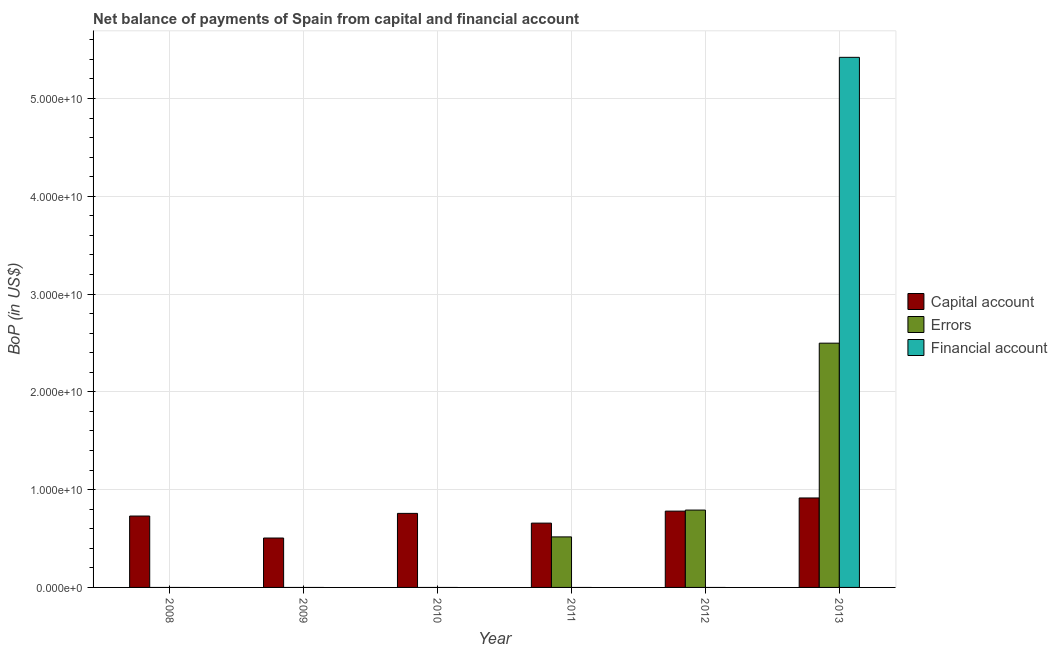Are the number of bars on each tick of the X-axis equal?
Your answer should be compact. No. How many bars are there on the 3rd tick from the right?
Your answer should be very brief. 2. What is the label of the 5th group of bars from the left?
Provide a succinct answer. 2012. What is the amount of net capital account in 2010?
Keep it short and to the point. 7.57e+09. Across all years, what is the maximum amount of net capital account?
Give a very brief answer. 9.15e+09. What is the total amount of financial account in the graph?
Keep it short and to the point. 5.42e+1. What is the difference between the amount of errors in 2011 and that in 2012?
Your answer should be very brief. -2.74e+09. What is the average amount of errors per year?
Your response must be concise. 6.34e+09. In how many years, is the amount of errors greater than 40000000000 US$?
Your answer should be compact. 0. What is the ratio of the amount of net capital account in 2009 to that in 2013?
Provide a succinct answer. 0.55. Is the amount of errors in 2011 less than that in 2012?
Your answer should be very brief. Yes. What is the difference between the highest and the second highest amount of net capital account?
Offer a very short reply. 1.35e+09. What is the difference between the highest and the lowest amount of financial account?
Provide a short and direct response. 5.42e+1. Are the values on the major ticks of Y-axis written in scientific E-notation?
Keep it short and to the point. Yes. Does the graph contain any zero values?
Provide a succinct answer. Yes. Does the graph contain grids?
Offer a terse response. Yes. Where does the legend appear in the graph?
Your response must be concise. Center right. How many legend labels are there?
Your response must be concise. 3. What is the title of the graph?
Your answer should be compact. Net balance of payments of Spain from capital and financial account. Does "Taxes" appear as one of the legend labels in the graph?
Ensure brevity in your answer.  No. What is the label or title of the X-axis?
Offer a terse response. Year. What is the label or title of the Y-axis?
Keep it short and to the point. BoP (in US$). What is the BoP (in US$) of Capital account in 2008?
Ensure brevity in your answer.  7.30e+09. What is the BoP (in US$) in Capital account in 2009?
Your response must be concise. 5.05e+09. What is the BoP (in US$) of Errors in 2009?
Provide a succinct answer. 0. What is the BoP (in US$) in Capital account in 2010?
Your answer should be very brief. 7.57e+09. What is the BoP (in US$) of Financial account in 2010?
Your answer should be compact. 0. What is the BoP (in US$) in Capital account in 2011?
Provide a succinct answer. 6.58e+09. What is the BoP (in US$) of Errors in 2011?
Give a very brief answer. 5.17e+09. What is the BoP (in US$) of Capital account in 2012?
Your response must be concise. 7.81e+09. What is the BoP (in US$) in Errors in 2012?
Your response must be concise. 7.91e+09. What is the BoP (in US$) in Capital account in 2013?
Keep it short and to the point. 9.15e+09. What is the BoP (in US$) of Errors in 2013?
Your answer should be compact. 2.50e+1. What is the BoP (in US$) of Financial account in 2013?
Ensure brevity in your answer.  5.42e+1. Across all years, what is the maximum BoP (in US$) of Capital account?
Make the answer very short. 9.15e+09. Across all years, what is the maximum BoP (in US$) of Errors?
Keep it short and to the point. 2.50e+1. Across all years, what is the maximum BoP (in US$) in Financial account?
Ensure brevity in your answer.  5.42e+1. Across all years, what is the minimum BoP (in US$) of Capital account?
Offer a very short reply. 5.05e+09. Across all years, what is the minimum BoP (in US$) in Financial account?
Keep it short and to the point. 0. What is the total BoP (in US$) in Capital account in the graph?
Make the answer very short. 4.35e+1. What is the total BoP (in US$) in Errors in the graph?
Provide a succinct answer. 3.81e+1. What is the total BoP (in US$) of Financial account in the graph?
Keep it short and to the point. 5.42e+1. What is the difference between the BoP (in US$) of Capital account in 2008 and that in 2009?
Provide a short and direct response. 2.25e+09. What is the difference between the BoP (in US$) in Capital account in 2008 and that in 2010?
Offer a very short reply. -2.73e+08. What is the difference between the BoP (in US$) of Capital account in 2008 and that in 2011?
Make the answer very short. 7.24e+08. What is the difference between the BoP (in US$) of Capital account in 2008 and that in 2012?
Your response must be concise. -5.05e+08. What is the difference between the BoP (in US$) in Capital account in 2008 and that in 2013?
Offer a terse response. -1.85e+09. What is the difference between the BoP (in US$) of Capital account in 2009 and that in 2010?
Your response must be concise. -2.52e+09. What is the difference between the BoP (in US$) in Capital account in 2009 and that in 2011?
Ensure brevity in your answer.  -1.52e+09. What is the difference between the BoP (in US$) in Capital account in 2009 and that in 2012?
Your answer should be very brief. -2.75e+09. What is the difference between the BoP (in US$) in Capital account in 2009 and that in 2013?
Provide a short and direct response. -4.10e+09. What is the difference between the BoP (in US$) in Capital account in 2010 and that in 2011?
Your answer should be compact. 9.97e+08. What is the difference between the BoP (in US$) in Capital account in 2010 and that in 2012?
Provide a short and direct response. -2.32e+08. What is the difference between the BoP (in US$) in Capital account in 2010 and that in 2013?
Ensure brevity in your answer.  -1.58e+09. What is the difference between the BoP (in US$) of Capital account in 2011 and that in 2012?
Give a very brief answer. -1.23e+09. What is the difference between the BoP (in US$) of Errors in 2011 and that in 2012?
Provide a short and direct response. -2.74e+09. What is the difference between the BoP (in US$) in Capital account in 2011 and that in 2013?
Your answer should be compact. -2.57e+09. What is the difference between the BoP (in US$) in Errors in 2011 and that in 2013?
Your answer should be very brief. -1.98e+1. What is the difference between the BoP (in US$) of Capital account in 2012 and that in 2013?
Provide a succinct answer. -1.35e+09. What is the difference between the BoP (in US$) in Errors in 2012 and that in 2013?
Keep it short and to the point. -1.71e+1. What is the difference between the BoP (in US$) in Capital account in 2008 and the BoP (in US$) in Errors in 2011?
Your answer should be compact. 2.13e+09. What is the difference between the BoP (in US$) in Capital account in 2008 and the BoP (in US$) in Errors in 2012?
Your answer should be very brief. -6.12e+08. What is the difference between the BoP (in US$) in Capital account in 2008 and the BoP (in US$) in Errors in 2013?
Your answer should be compact. -1.77e+1. What is the difference between the BoP (in US$) in Capital account in 2008 and the BoP (in US$) in Financial account in 2013?
Offer a very short reply. -4.69e+1. What is the difference between the BoP (in US$) of Capital account in 2009 and the BoP (in US$) of Errors in 2011?
Offer a very short reply. -1.15e+08. What is the difference between the BoP (in US$) of Capital account in 2009 and the BoP (in US$) of Errors in 2012?
Provide a short and direct response. -2.86e+09. What is the difference between the BoP (in US$) of Capital account in 2009 and the BoP (in US$) of Errors in 2013?
Provide a short and direct response. -1.99e+1. What is the difference between the BoP (in US$) of Capital account in 2009 and the BoP (in US$) of Financial account in 2013?
Provide a succinct answer. -4.92e+1. What is the difference between the BoP (in US$) in Capital account in 2010 and the BoP (in US$) in Errors in 2011?
Provide a short and direct response. 2.41e+09. What is the difference between the BoP (in US$) of Capital account in 2010 and the BoP (in US$) of Errors in 2012?
Ensure brevity in your answer.  -3.39e+08. What is the difference between the BoP (in US$) of Capital account in 2010 and the BoP (in US$) of Errors in 2013?
Your answer should be very brief. -1.74e+1. What is the difference between the BoP (in US$) of Capital account in 2010 and the BoP (in US$) of Financial account in 2013?
Provide a succinct answer. -4.66e+1. What is the difference between the BoP (in US$) of Capital account in 2011 and the BoP (in US$) of Errors in 2012?
Provide a succinct answer. -1.34e+09. What is the difference between the BoP (in US$) in Capital account in 2011 and the BoP (in US$) in Errors in 2013?
Offer a very short reply. -1.84e+1. What is the difference between the BoP (in US$) of Capital account in 2011 and the BoP (in US$) of Financial account in 2013?
Offer a terse response. -4.76e+1. What is the difference between the BoP (in US$) in Errors in 2011 and the BoP (in US$) in Financial account in 2013?
Give a very brief answer. -4.90e+1. What is the difference between the BoP (in US$) in Capital account in 2012 and the BoP (in US$) in Errors in 2013?
Offer a terse response. -1.72e+1. What is the difference between the BoP (in US$) of Capital account in 2012 and the BoP (in US$) of Financial account in 2013?
Provide a short and direct response. -4.64e+1. What is the difference between the BoP (in US$) of Errors in 2012 and the BoP (in US$) of Financial account in 2013?
Ensure brevity in your answer.  -4.63e+1. What is the average BoP (in US$) in Capital account per year?
Your answer should be compact. 7.24e+09. What is the average BoP (in US$) of Errors per year?
Ensure brevity in your answer.  6.34e+09. What is the average BoP (in US$) in Financial account per year?
Your answer should be compact. 9.04e+09. In the year 2011, what is the difference between the BoP (in US$) of Capital account and BoP (in US$) of Errors?
Make the answer very short. 1.41e+09. In the year 2012, what is the difference between the BoP (in US$) in Capital account and BoP (in US$) in Errors?
Your answer should be very brief. -1.07e+08. In the year 2013, what is the difference between the BoP (in US$) in Capital account and BoP (in US$) in Errors?
Provide a succinct answer. -1.58e+1. In the year 2013, what is the difference between the BoP (in US$) of Capital account and BoP (in US$) of Financial account?
Your answer should be compact. -4.51e+1. In the year 2013, what is the difference between the BoP (in US$) of Errors and BoP (in US$) of Financial account?
Provide a short and direct response. -2.92e+1. What is the ratio of the BoP (in US$) of Capital account in 2008 to that in 2009?
Offer a very short reply. 1.44. What is the ratio of the BoP (in US$) in Capital account in 2008 to that in 2011?
Make the answer very short. 1.11. What is the ratio of the BoP (in US$) in Capital account in 2008 to that in 2012?
Provide a succinct answer. 0.94. What is the ratio of the BoP (in US$) in Capital account in 2008 to that in 2013?
Your answer should be compact. 0.8. What is the ratio of the BoP (in US$) of Capital account in 2009 to that in 2010?
Your answer should be compact. 0.67. What is the ratio of the BoP (in US$) in Capital account in 2009 to that in 2011?
Offer a very short reply. 0.77. What is the ratio of the BoP (in US$) of Capital account in 2009 to that in 2012?
Your answer should be compact. 0.65. What is the ratio of the BoP (in US$) of Capital account in 2009 to that in 2013?
Ensure brevity in your answer.  0.55. What is the ratio of the BoP (in US$) in Capital account in 2010 to that in 2011?
Ensure brevity in your answer.  1.15. What is the ratio of the BoP (in US$) of Capital account in 2010 to that in 2012?
Provide a short and direct response. 0.97. What is the ratio of the BoP (in US$) in Capital account in 2010 to that in 2013?
Your response must be concise. 0.83. What is the ratio of the BoP (in US$) of Capital account in 2011 to that in 2012?
Provide a succinct answer. 0.84. What is the ratio of the BoP (in US$) in Errors in 2011 to that in 2012?
Your answer should be very brief. 0.65. What is the ratio of the BoP (in US$) in Capital account in 2011 to that in 2013?
Your answer should be very brief. 0.72. What is the ratio of the BoP (in US$) of Errors in 2011 to that in 2013?
Provide a succinct answer. 0.21. What is the ratio of the BoP (in US$) in Capital account in 2012 to that in 2013?
Keep it short and to the point. 0.85. What is the ratio of the BoP (in US$) of Errors in 2012 to that in 2013?
Make the answer very short. 0.32. What is the difference between the highest and the second highest BoP (in US$) of Capital account?
Keep it short and to the point. 1.35e+09. What is the difference between the highest and the second highest BoP (in US$) of Errors?
Keep it short and to the point. 1.71e+1. What is the difference between the highest and the lowest BoP (in US$) in Capital account?
Keep it short and to the point. 4.10e+09. What is the difference between the highest and the lowest BoP (in US$) in Errors?
Offer a terse response. 2.50e+1. What is the difference between the highest and the lowest BoP (in US$) in Financial account?
Provide a succinct answer. 5.42e+1. 